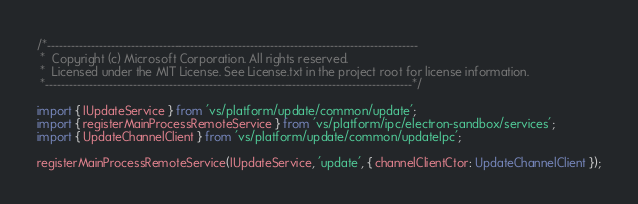Convert code to text. <code><loc_0><loc_0><loc_500><loc_500><_TypeScript_>/*---------------------------------------------------------------------------------------------
 *  Copyright (c) Microsoft Corporation. All rights reserved.
 *  Licensed under the MIT License. See License.txt in the project root for license information.
 *--------------------------------------------------------------------------------------------*/

import { IUpdateService } from 'vs/platform/update/common/update';
import { registerMainProcessRemoteService } from 'vs/platform/ipc/electron-sandbox/services';
import { UpdateChannelClient } from 'vs/platform/update/common/updateIpc';

registerMainProcessRemoteService(IUpdateService, 'update', { channelClientCtor: UpdateChannelClient });
</code> 